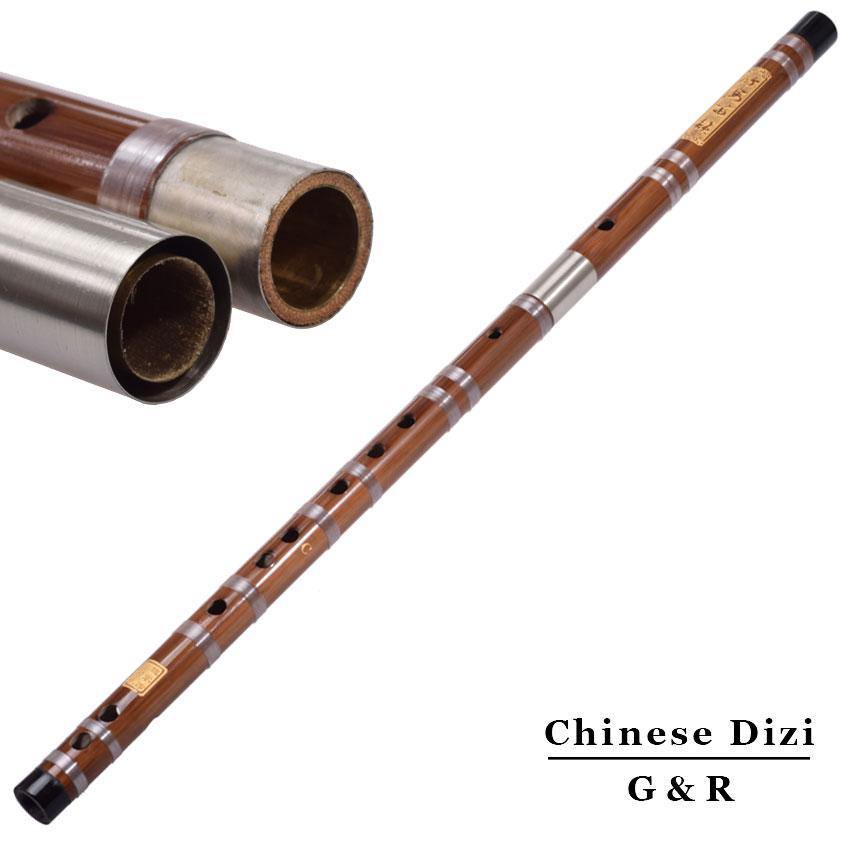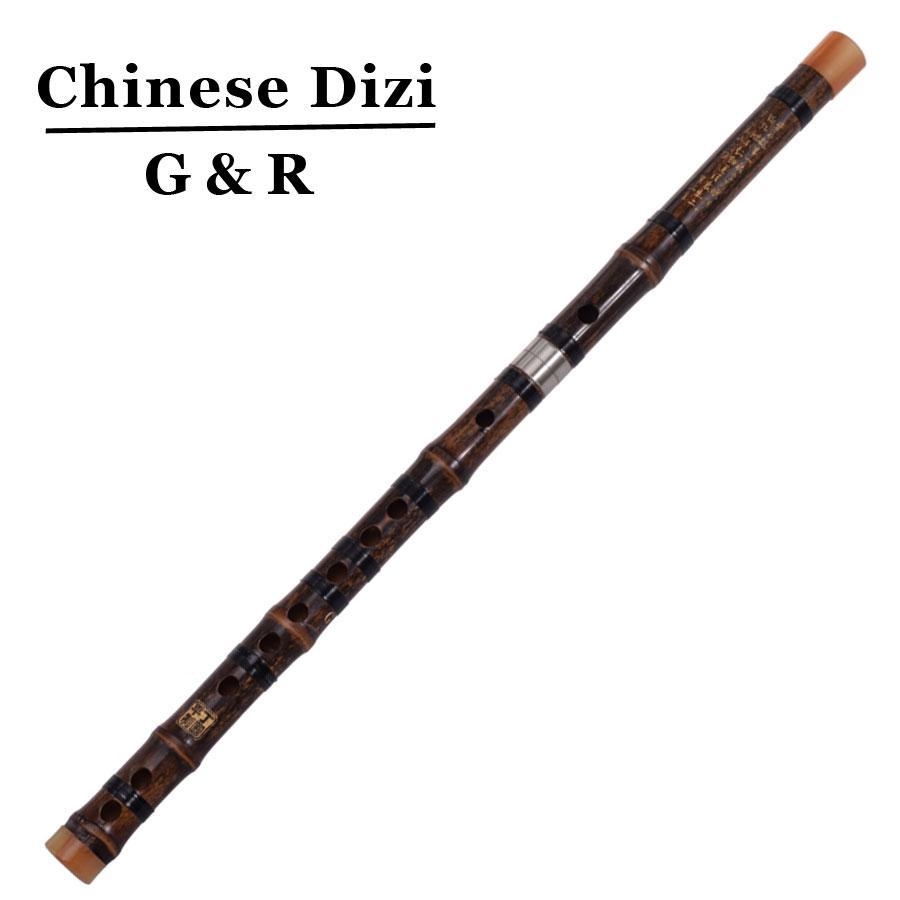The first image is the image on the left, the second image is the image on the right. Examine the images to the left and right. Is the description "There are at least two metal wind instruments." accurate? Answer yes or no. No. The first image is the image on the left, the second image is the image on the right. Given the left and right images, does the statement "There are exactly two assembled flutes." hold true? Answer yes or no. Yes. 